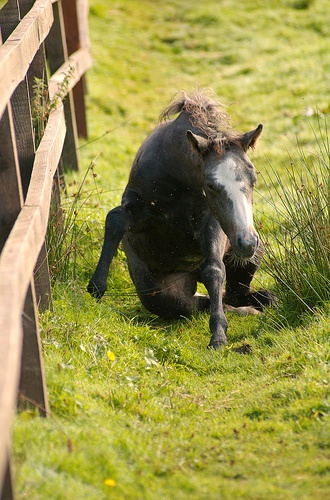Describe the objects in this image and their specific colors. I can see a horse in olive, black, gray, darkgray, and darkgreen tones in this image. 